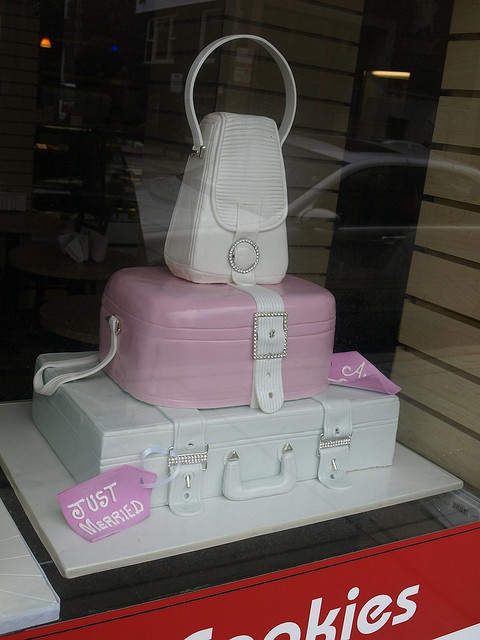Describe the objects in this image and their specific colors. I can see car in black and gray tones, suitcase in black, darkgray, gray, and lightgray tones, handbag in black, darkgray, gray, and lightgray tones, and suitcase in black, darkgray, and gray tones in this image. 